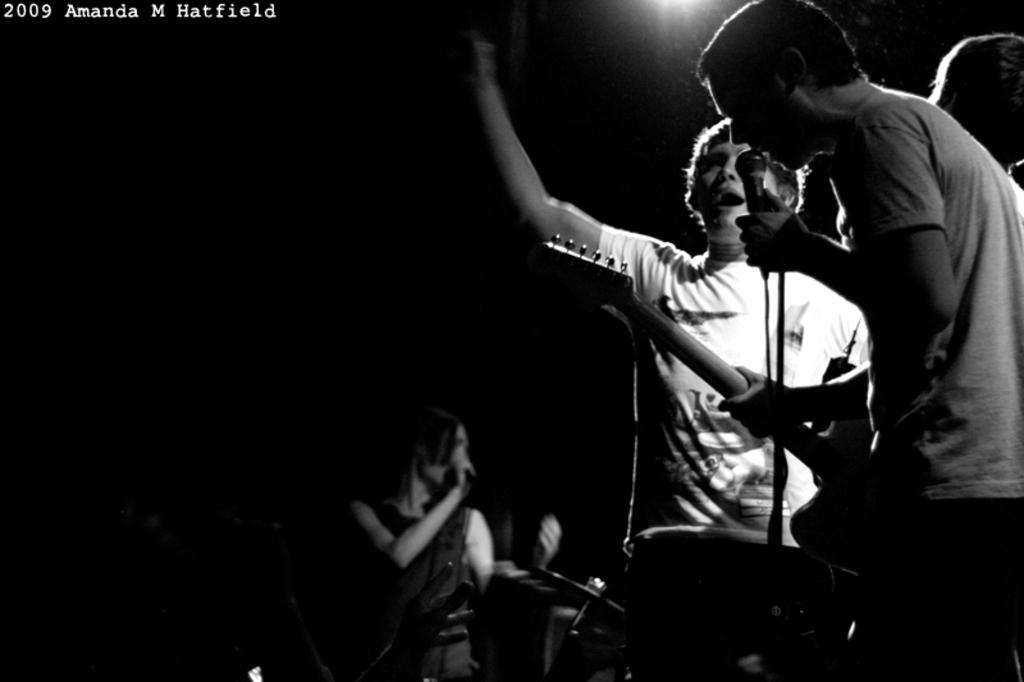What is happening in the image involving a group of people? The group of people are singing a song. What can be seen in front of the group of people? They are standing in front of a microphone. How many men and women are in the group? There are two men and one woman in the group. What type of fact is being presented by the government in the image? There is no mention of a fact or the government in the image; it features a group of people singing in front of a microphone. 